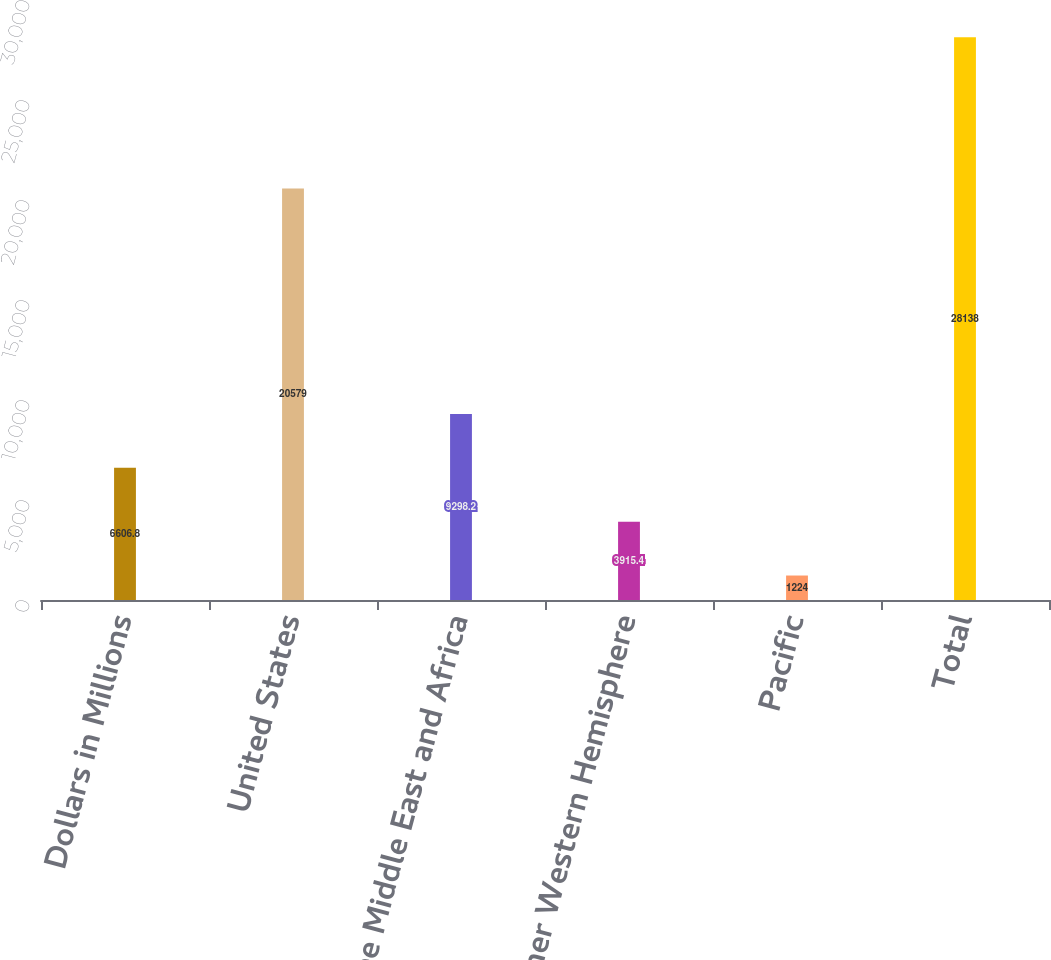Convert chart. <chart><loc_0><loc_0><loc_500><loc_500><bar_chart><fcel>Dollars in Millions<fcel>United States<fcel>Europe Middle East and Africa<fcel>Other Western Hemisphere<fcel>Pacific<fcel>Total<nl><fcel>6606.8<fcel>20579<fcel>9298.2<fcel>3915.4<fcel>1224<fcel>28138<nl></chart> 